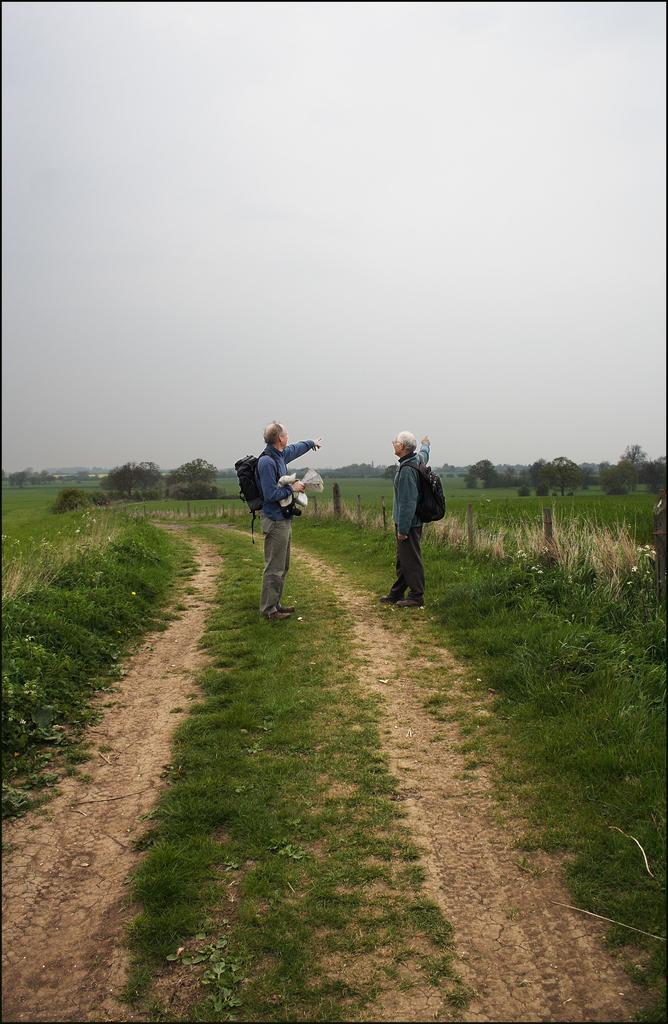Describe this image in one or two sentences. In this picture, there are fields on either side of the lane which is in the center. On the lane, there are two people carrying bags. They are facing each other. In the background, there are trees and sky. 